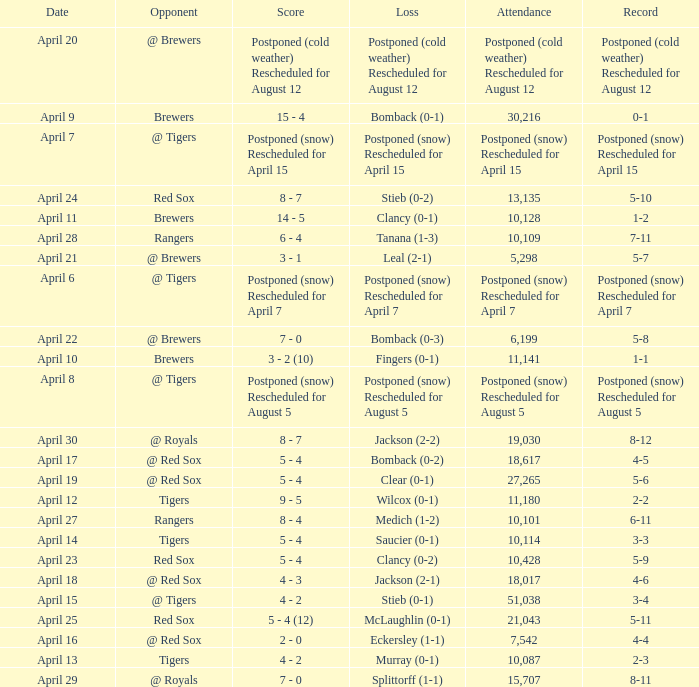Would you mind parsing the complete table? {'header': ['Date', 'Opponent', 'Score', 'Loss', 'Attendance', 'Record'], 'rows': [['April 20', '@ Brewers', 'Postponed (cold weather) Rescheduled for August 12', 'Postponed (cold weather) Rescheduled for August 12', 'Postponed (cold weather) Rescheduled for August 12', 'Postponed (cold weather) Rescheduled for August 12'], ['April 9', 'Brewers', '15 - 4', 'Bomback (0-1)', '30,216', '0-1'], ['April 7', '@ Tigers', 'Postponed (snow) Rescheduled for April 15', 'Postponed (snow) Rescheduled for April 15', 'Postponed (snow) Rescheduled for April 15', 'Postponed (snow) Rescheduled for April 15'], ['April 24', 'Red Sox', '8 - 7', 'Stieb (0-2)', '13,135', '5-10'], ['April 11', 'Brewers', '14 - 5', 'Clancy (0-1)', '10,128', '1-2'], ['April 28', 'Rangers', '6 - 4', 'Tanana (1-3)', '10,109', '7-11'], ['April 21', '@ Brewers', '3 - 1', 'Leal (2-1)', '5,298', '5-7'], ['April 6', '@ Tigers', 'Postponed (snow) Rescheduled for April 7', 'Postponed (snow) Rescheduled for April 7', 'Postponed (snow) Rescheduled for April 7', 'Postponed (snow) Rescheduled for April 7'], ['April 22', '@ Brewers', '7 - 0', 'Bomback (0-3)', '6,199', '5-8'], ['April 10', 'Brewers', '3 - 2 (10)', 'Fingers (0-1)', '11,141', '1-1'], ['April 8', '@ Tigers', 'Postponed (snow) Rescheduled for August 5', 'Postponed (snow) Rescheduled for August 5', 'Postponed (snow) Rescheduled for August 5', 'Postponed (snow) Rescheduled for August 5'], ['April 30', '@ Royals', '8 - 7', 'Jackson (2-2)', '19,030', '8-12'], ['April 17', '@ Red Sox', '5 - 4', 'Bomback (0-2)', '18,617', '4-5'], ['April 19', '@ Red Sox', '5 - 4', 'Clear (0-1)', '27,265', '5-6'], ['April 12', 'Tigers', '9 - 5', 'Wilcox (0-1)', '11,180', '2-2'], ['April 27', 'Rangers', '8 - 4', 'Medich (1-2)', '10,101', '6-11'], ['April 14', 'Tigers', '5 - 4', 'Saucier (0-1)', '10,114', '3-3'], ['April 23', 'Red Sox', '5 - 4', 'Clancy (0-2)', '10,428', '5-9'], ['April 18', '@ Red Sox', '4 - 3', 'Jackson (2-1)', '18,017', '4-6'], ['April 15', '@ Tigers', '4 - 2', 'Stieb (0-1)', '51,038', '3-4'], ['April 25', 'Red Sox', '5 - 4 (12)', 'McLaughlin (0-1)', '21,043', '5-11'], ['April 16', '@ Red Sox', '2 - 0', 'Eckersley (1-1)', '7,542', '4-4'], ['April 13', 'Tigers', '4 - 2', 'Murray (0-1)', '10,087', '2-3'], ['April 29', '@ Royals', '7 - 0', 'Splittorff (1-1)', '15,707', '8-11']]} What is the score for the game that has an attendance of 5,298? 3 - 1. 